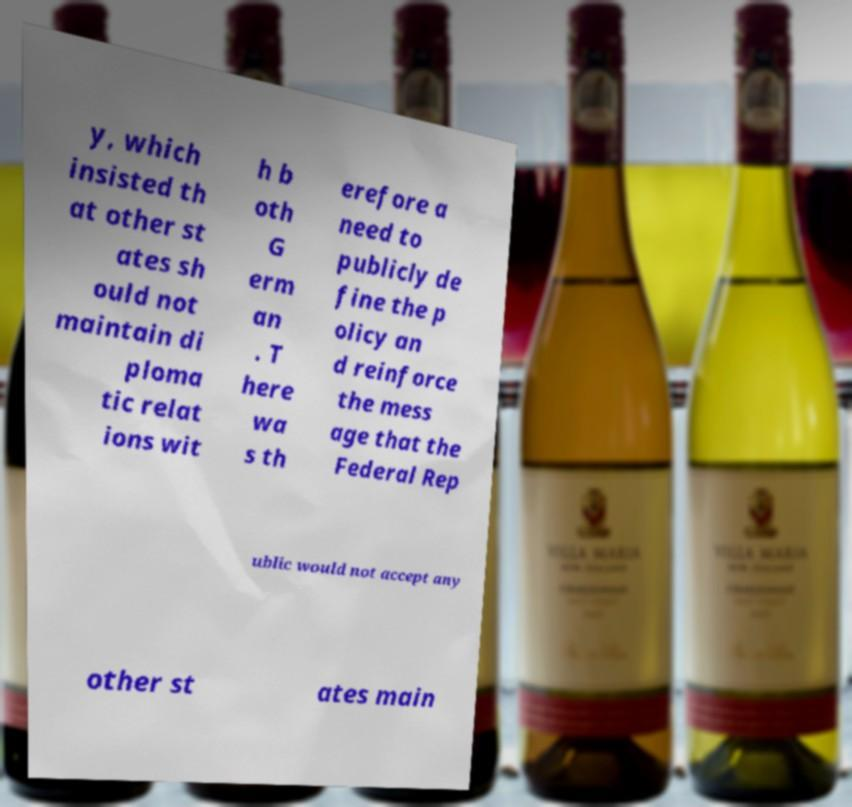Could you extract and type out the text from this image? y, which insisted th at other st ates sh ould not maintain di ploma tic relat ions wit h b oth G erm an . T here wa s th erefore a need to publicly de fine the p olicy an d reinforce the mess age that the Federal Rep ublic would not accept any other st ates main 